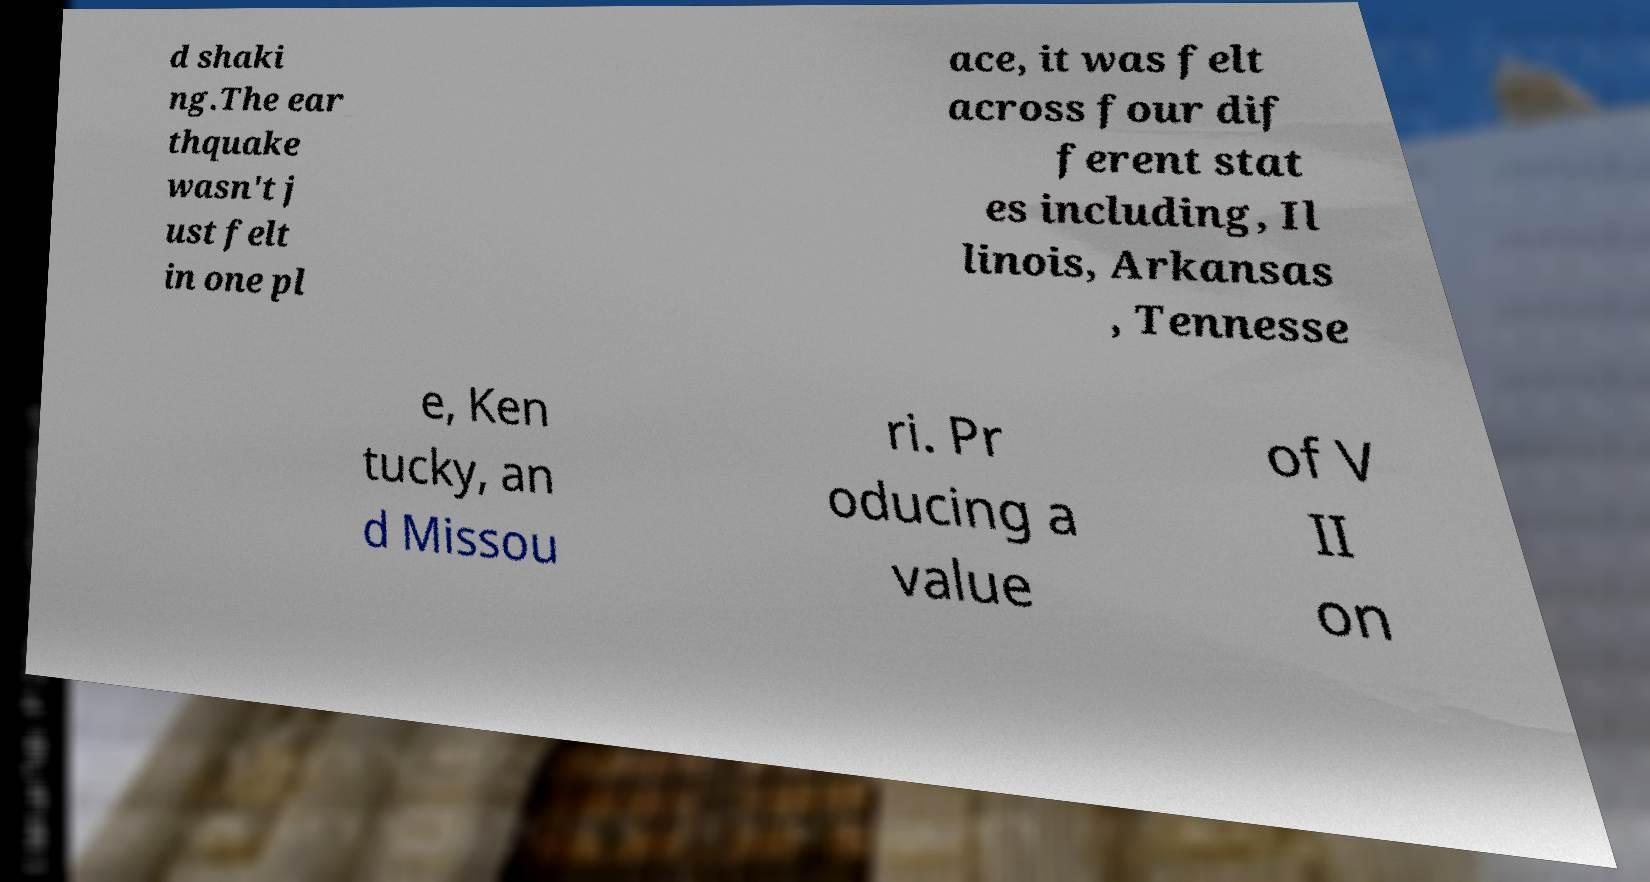Could you assist in decoding the text presented in this image and type it out clearly? d shaki ng.The ear thquake wasn't j ust felt in one pl ace, it was felt across four dif ferent stat es including, Il linois, Arkansas , Tennesse e, Ken tucky, an d Missou ri. Pr oducing a value of V II on 